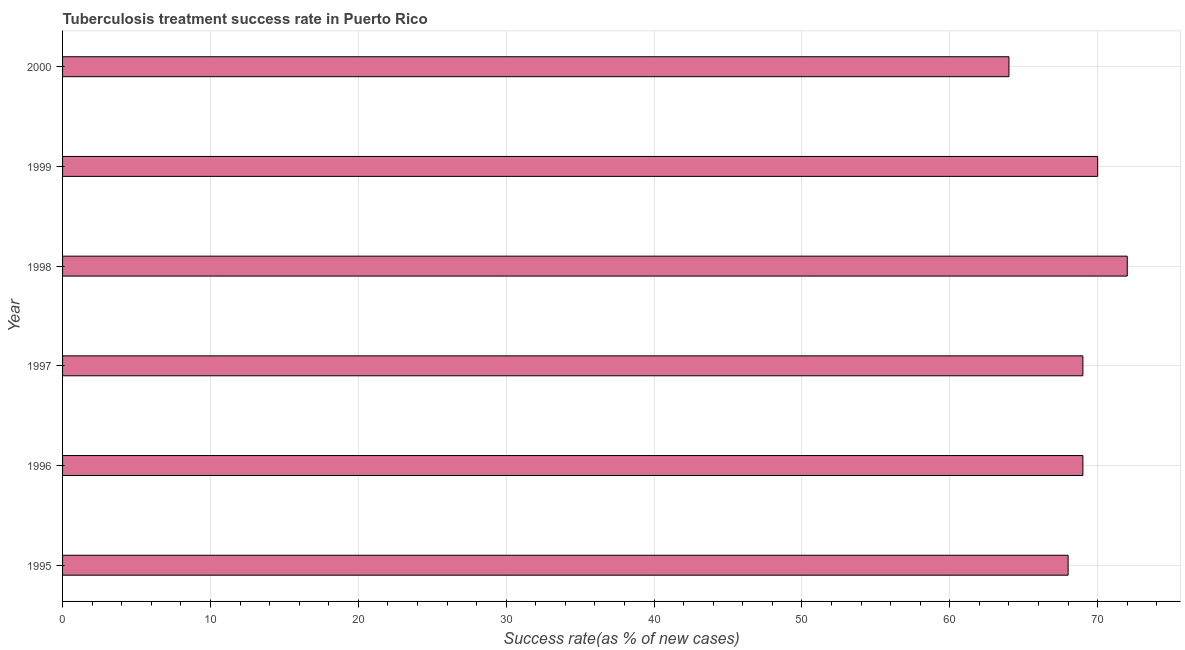What is the title of the graph?
Provide a succinct answer. Tuberculosis treatment success rate in Puerto Rico. What is the label or title of the X-axis?
Provide a short and direct response. Success rate(as % of new cases). What is the label or title of the Y-axis?
Your response must be concise. Year. In which year was the tuberculosis treatment success rate maximum?
Provide a short and direct response. 1998. What is the sum of the tuberculosis treatment success rate?
Provide a succinct answer. 412. What is the difference between the tuberculosis treatment success rate in 1998 and 1999?
Provide a short and direct response. 2. In how many years, is the tuberculosis treatment success rate greater than 16 %?
Give a very brief answer. 6. Do a majority of the years between 1999 and 1997 (inclusive) have tuberculosis treatment success rate greater than 32 %?
Offer a terse response. Yes. What is the ratio of the tuberculosis treatment success rate in 1996 to that in 1999?
Your answer should be very brief. 0.99. Is the tuberculosis treatment success rate in 1999 less than that in 2000?
Provide a short and direct response. No. Is the difference between the tuberculosis treatment success rate in 1997 and 2000 greater than the difference between any two years?
Your answer should be compact. No. Is the sum of the tuberculosis treatment success rate in 1999 and 2000 greater than the maximum tuberculosis treatment success rate across all years?
Your answer should be compact. Yes. In how many years, is the tuberculosis treatment success rate greater than the average tuberculosis treatment success rate taken over all years?
Your answer should be compact. 4. How many bars are there?
Your answer should be compact. 6. Are all the bars in the graph horizontal?
Provide a short and direct response. Yes. What is the Success rate(as % of new cases) in 1996?
Keep it short and to the point. 69. What is the Success rate(as % of new cases) in 1998?
Give a very brief answer. 72. What is the Success rate(as % of new cases) in 1999?
Your response must be concise. 70. What is the Success rate(as % of new cases) of 2000?
Make the answer very short. 64. What is the difference between the Success rate(as % of new cases) in 1995 and 1996?
Provide a succinct answer. -1. What is the difference between the Success rate(as % of new cases) in 1995 and 1997?
Your answer should be very brief. -1. What is the difference between the Success rate(as % of new cases) in 1995 and 2000?
Ensure brevity in your answer.  4. What is the difference between the Success rate(as % of new cases) in 1996 and 1997?
Your answer should be compact. 0. What is the difference between the Success rate(as % of new cases) in 1996 and 2000?
Your answer should be very brief. 5. What is the difference between the Success rate(as % of new cases) in 1997 and 1998?
Provide a short and direct response. -3. What is the difference between the Success rate(as % of new cases) in 1997 and 1999?
Ensure brevity in your answer.  -1. What is the difference between the Success rate(as % of new cases) in 1997 and 2000?
Your answer should be compact. 5. What is the difference between the Success rate(as % of new cases) in 1998 and 1999?
Offer a very short reply. 2. What is the ratio of the Success rate(as % of new cases) in 1995 to that in 1998?
Make the answer very short. 0.94. What is the ratio of the Success rate(as % of new cases) in 1995 to that in 1999?
Your answer should be very brief. 0.97. What is the ratio of the Success rate(as % of new cases) in 1995 to that in 2000?
Ensure brevity in your answer.  1.06. What is the ratio of the Success rate(as % of new cases) in 1996 to that in 1998?
Make the answer very short. 0.96. What is the ratio of the Success rate(as % of new cases) in 1996 to that in 2000?
Make the answer very short. 1.08. What is the ratio of the Success rate(as % of new cases) in 1997 to that in 1998?
Make the answer very short. 0.96. What is the ratio of the Success rate(as % of new cases) in 1997 to that in 2000?
Provide a short and direct response. 1.08. What is the ratio of the Success rate(as % of new cases) in 1999 to that in 2000?
Give a very brief answer. 1.09. 